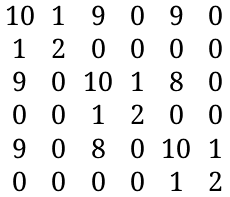<formula> <loc_0><loc_0><loc_500><loc_500>\begin{matrix} 1 0 & 1 & 9 & 0 & 9 & 0 \\ 1 & 2 & 0 & 0 & 0 & 0 \\ 9 & 0 & 1 0 & 1 & 8 & 0 \\ 0 & 0 & 1 & 2 & 0 & 0 \\ 9 & 0 & 8 & 0 & 1 0 & 1 \\ 0 & 0 & 0 & 0 & 1 & 2 \end{matrix}</formula> 